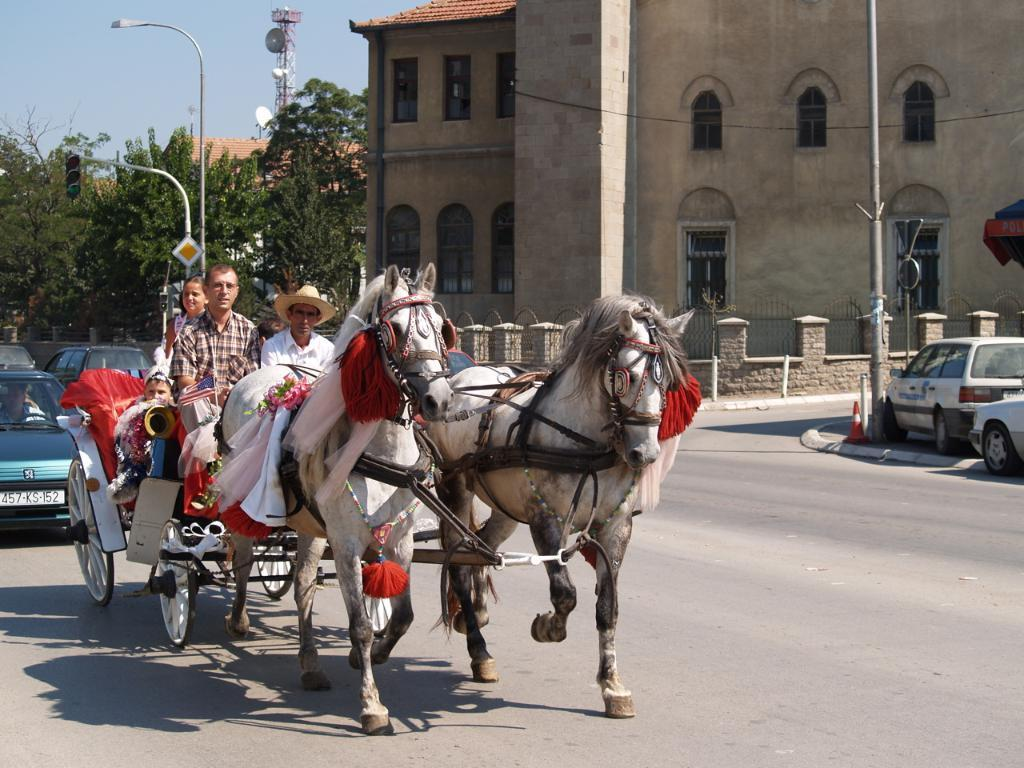What animals are in the foreground of the image? There are two horses in the foreground of the image. What else can be seen on the ground in the image? There are vehicles visible on the ground in the image. What type of vest is the horse wearing in the image? There are no vests present in the image, and the horses are not wearing any clothing. 